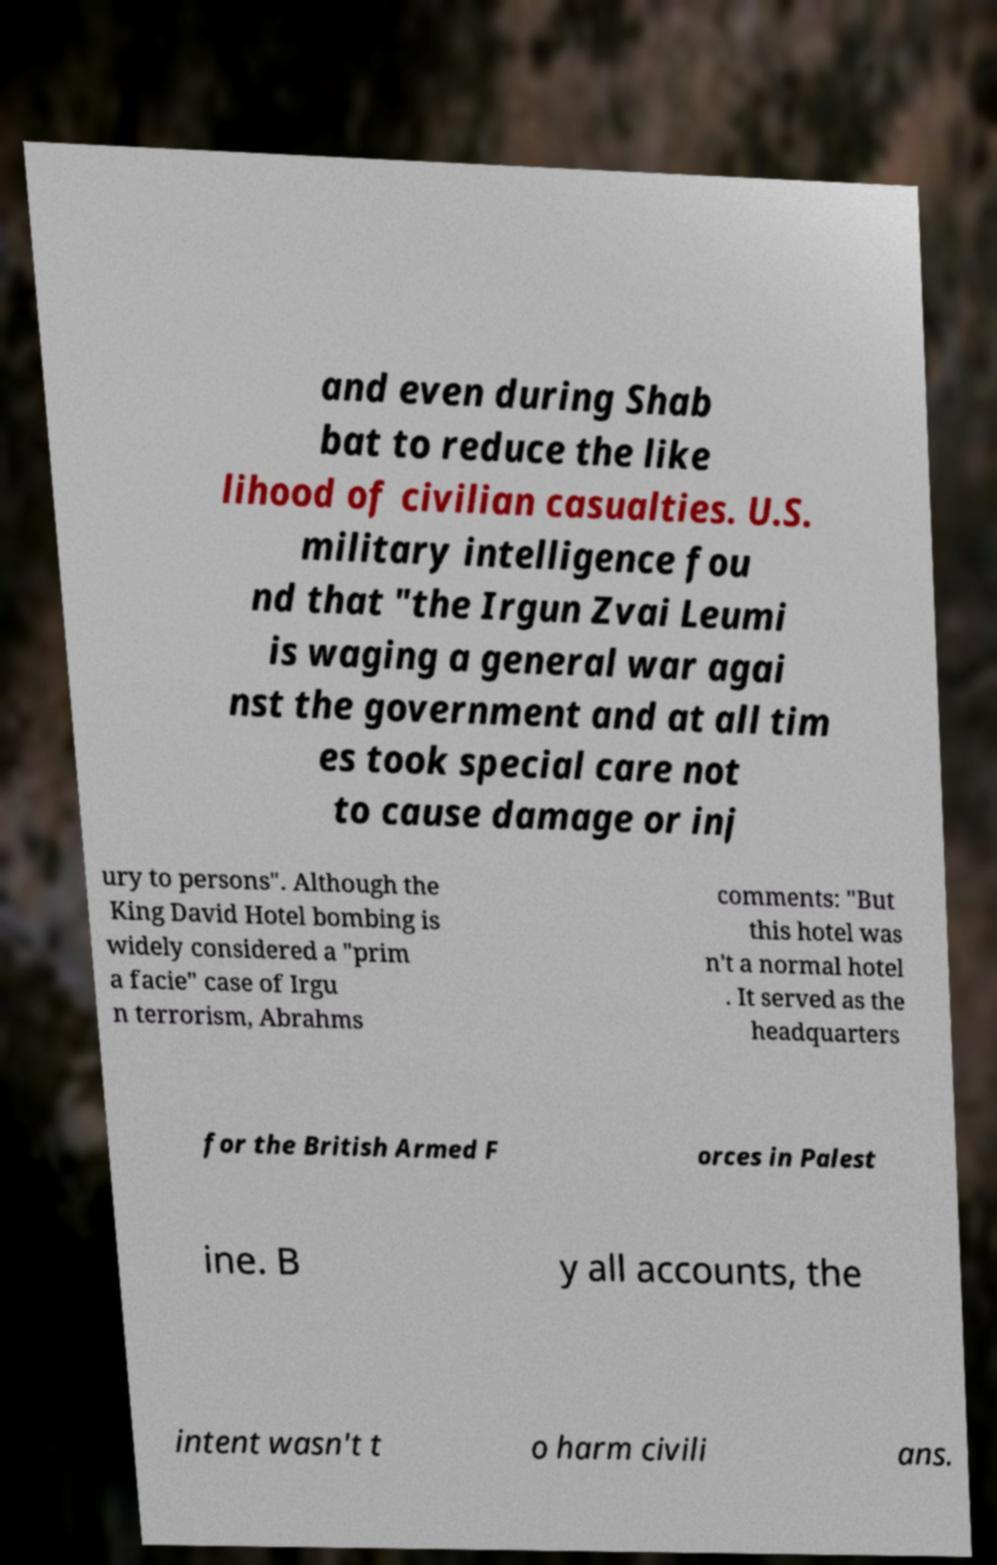Can you read and provide the text displayed in the image?This photo seems to have some interesting text. Can you extract and type it out for me? and even during Shab bat to reduce the like lihood of civilian casualties. U.S. military intelligence fou nd that "the Irgun Zvai Leumi is waging a general war agai nst the government and at all tim es took special care not to cause damage or inj ury to persons". Although the King David Hotel bombing is widely considered a "prim a facie" case of Irgu n terrorism, Abrahms comments: "But this hotel was n't a normal hotel . It served as the headquarters for the British Armed F orces in Palest ine. B y all accounts, the intent wasn't t o harm civili ans. 